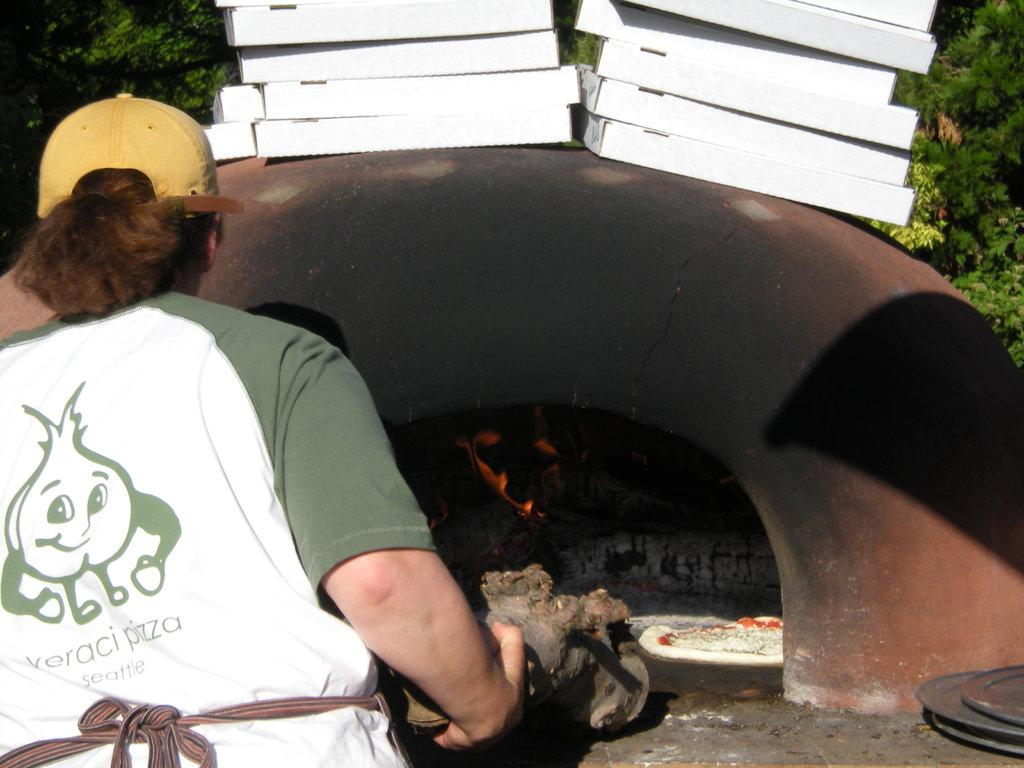<image>
Describe the image concisely. An employee of Veraci Pizza Seattle making a pizza in an outdoor oven 